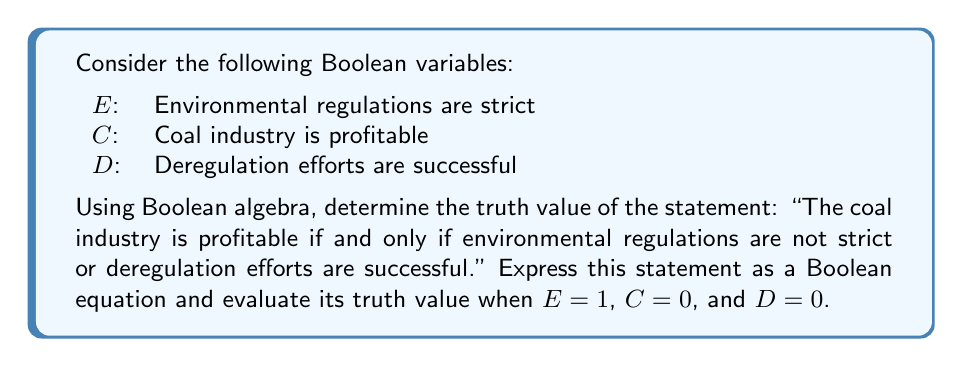Solve this math problem. 1) First, let's express the statement as a Boolean equation:

   $C \Leftrightarrow (\neg E \vee D)$

2) The truth table for this equation would be:

   $$\begin{array}{|c|c|c|c|}
   \hline
   E & C & D & C \Leftrightarrow (\neg E \vee D) \\
   \hline
   0 & 0 & 0 & 1 \\
   0 & 0 & 1 & 1 \\
   0 & 1 & 0 & 1 \\
   0 & 1 & 1 & 1 \\
   1 & 0 & 0 & 1 \\
   1 & 0 & 1 & 0 \\
   1 & 1 & 0 & 0 \\
   1 & 1 & 1 & 1 \\
   \hline
   \end{array}$$

3) Given $E = 1$, $C = 0$, and $D = 0$, we need to evaluate:

   $0 \Leftrightarrow (\neg 1 \vee 0)$

4) Simplify the right side:
   $\neg 1 \vee 0 = 0 \vee 0 = 0$

5) Now we have:
   $0 \Leftrightarrow 0$

6) The biconditional operator $\Leftrightarrow$ returns true when both sides are the same. In this case, both sides are 0, so the result is true (1).
Answer: 1 